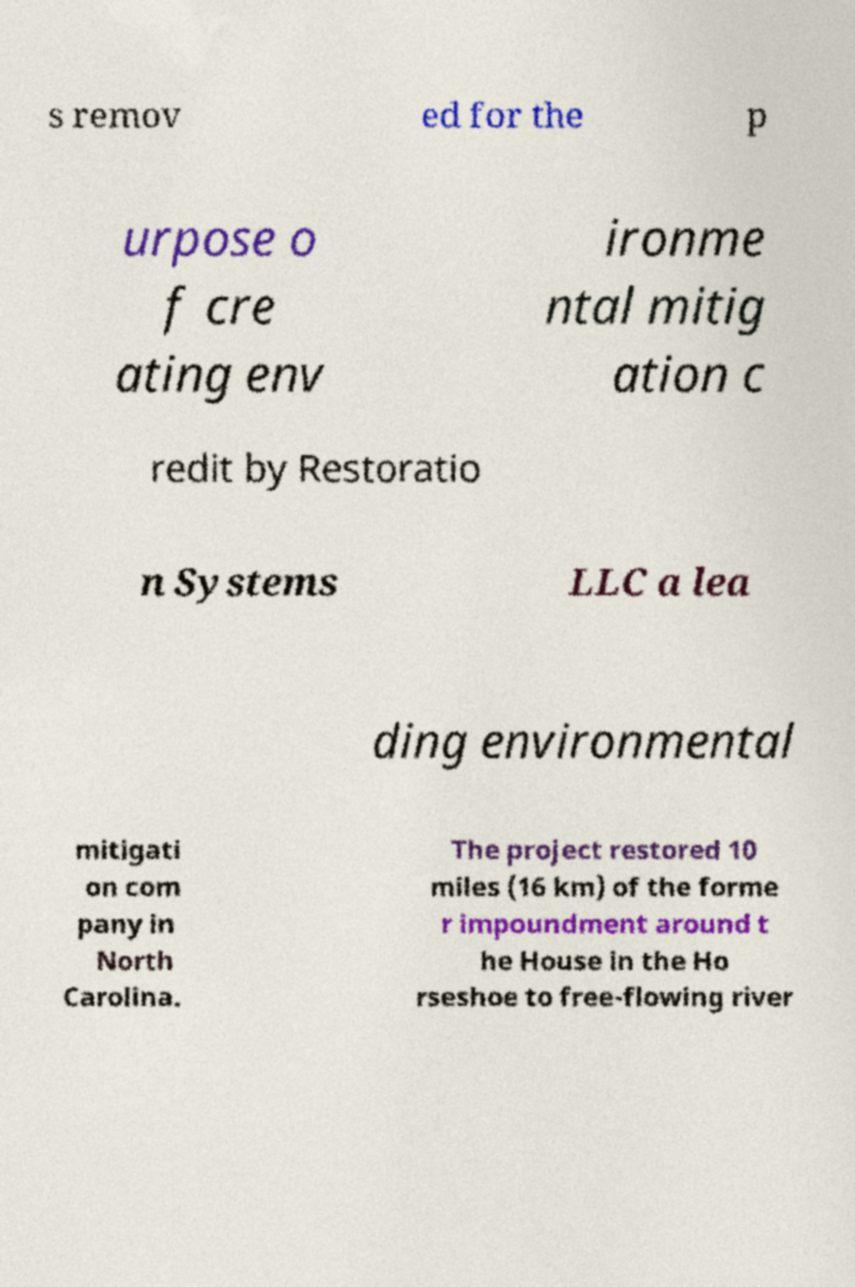Could you assist in decoding the text presented in this image and type it out clearly? s remov ed for the p urpose o f cre ating env ironme ntal mitig ation c redit by Restoratio n Systems LLC a lea ding environmental mitigati on com pany in North Carolina. The project restored 10 miles (16 km) of the forme r impoundment around t he House in the Ho rseshoe to free-flowing river 